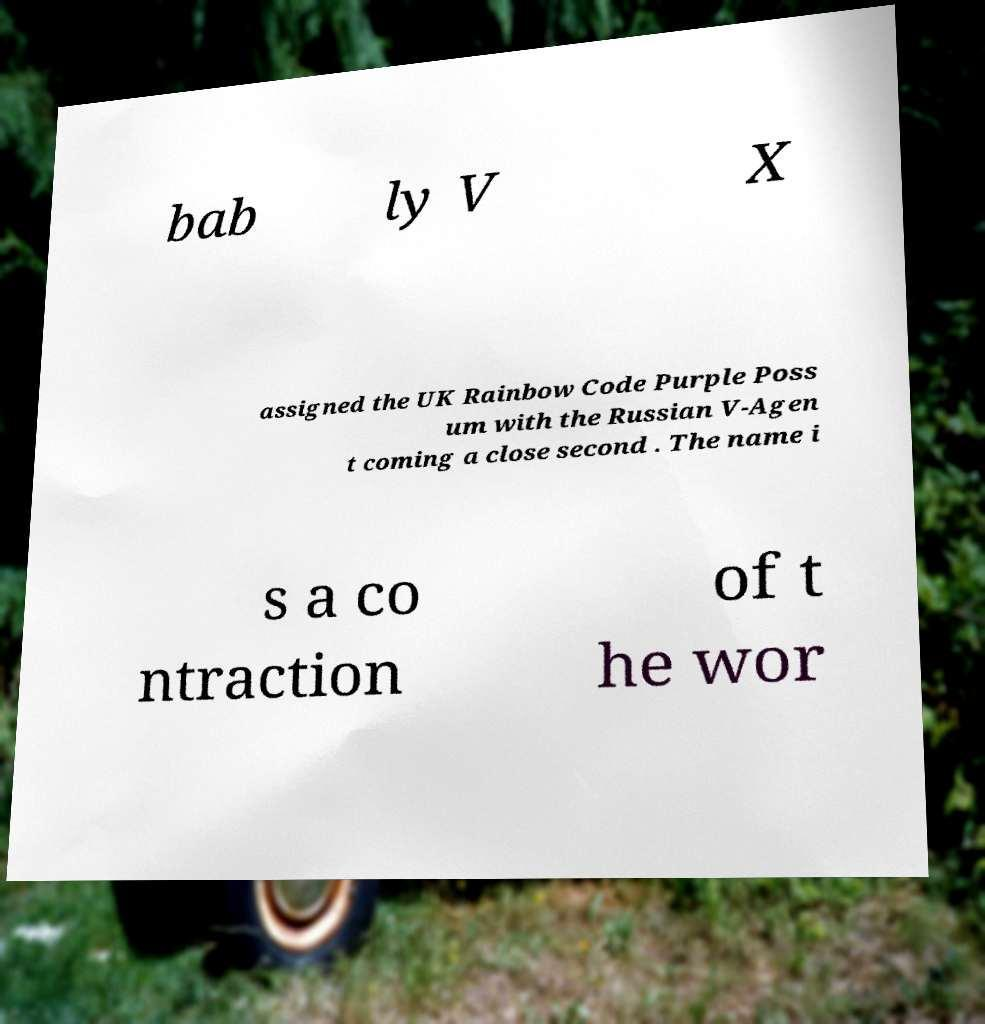There's text embedded in this image that I need extracted. Can you transcribe it verbatim? bab ly V X assigned the UK Rainbow Code Purple Poss um with the Russian V-Agen t coming a close second . The name i s a co ntraction of t he wor 